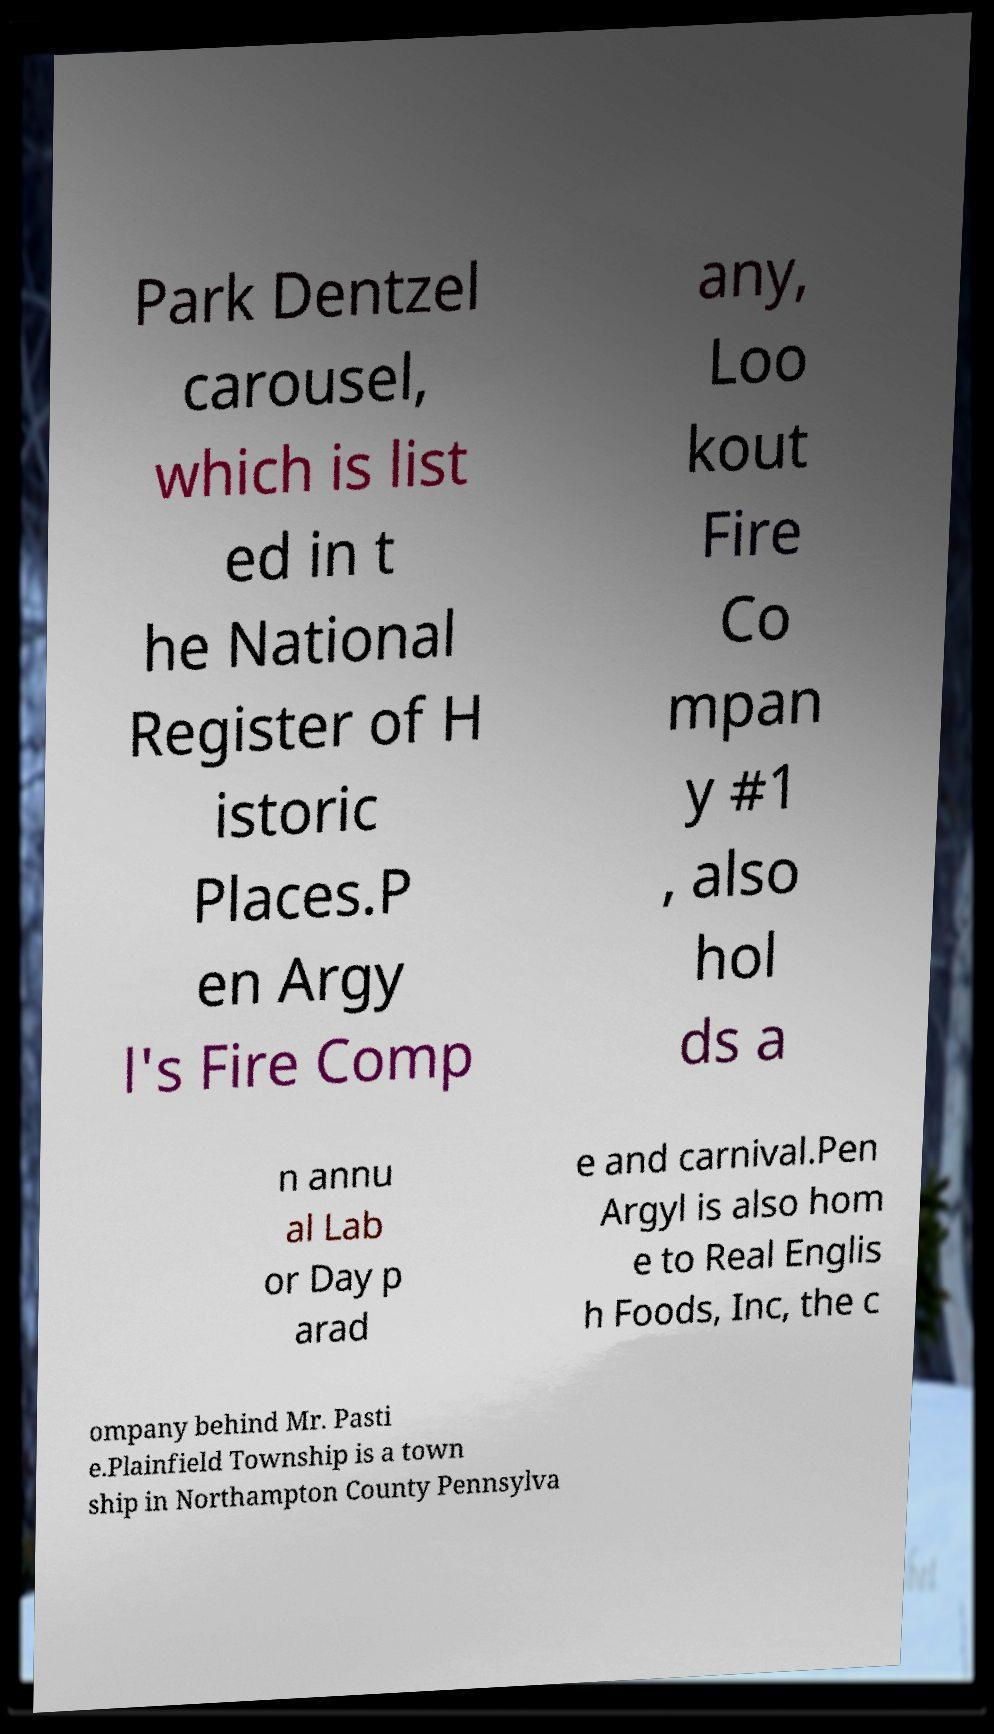There's text embedded in this image that I need extracted. Can you transcribe it verbatim? Park Dentzel carousel, which is list ed in t he National Register of H istoric Places.P en Argy l's Fire Comp any, Loo kout Fire Co mpan y #1 , also hol ds a n annu al Lab or Day p arad e and carnival.Pen Argyl is also hom e to Real Englis h Foods, Inc, the c ompany behind Mr. Pasti e.Plainfield Township is a town ship in Northampton County Pennsylva 